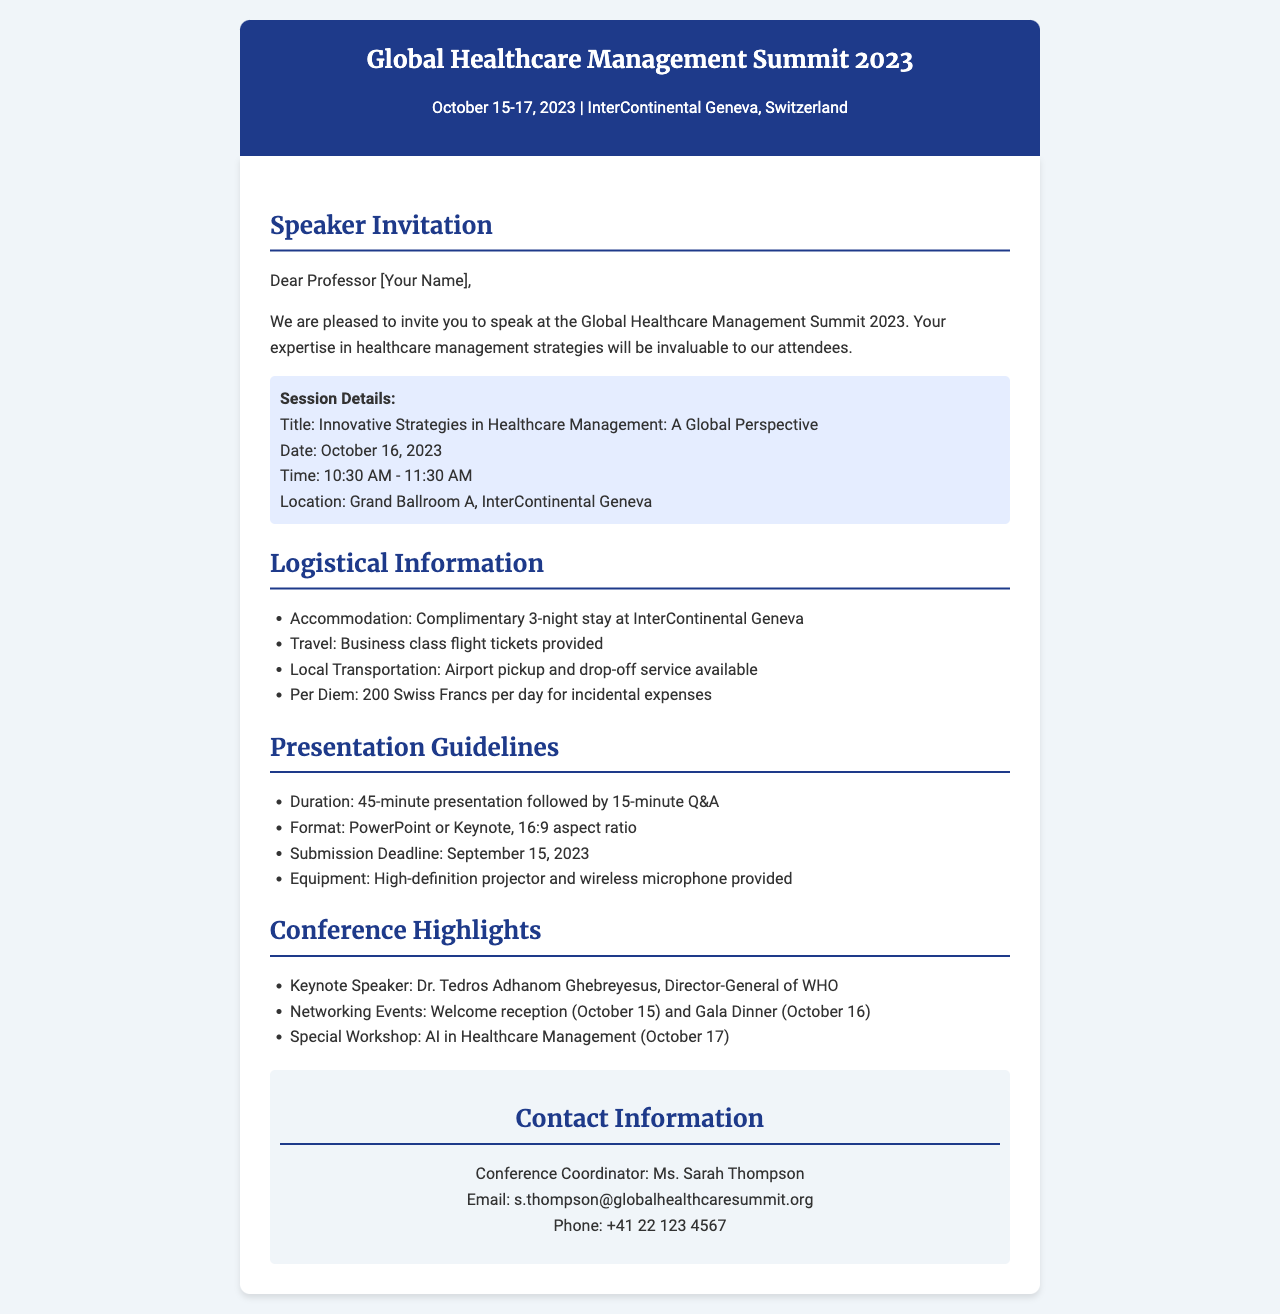What are the dates of the conference? The conference is scheduled to take place from October 15 to October 17, 2023.
Answer: October 15-17, 2023 Who is the keynote speaker? The document specifies that Dr. Tedros Adhanom Ghebreyesus is the keynote speaker.
Answer: Dr. Tedros Adhanom Ghebreyesus What is the title of the session? The session title mentioned in the document is "Innovative Strategies in Healthcare Management: A Global Perspective."
Answer: Innovative Strategies in Healthcare Management: A Global Perspective What is the duration of the presentation? The duration outlined in the document includes a 45-minute presentation followed by a 15-minute Q&A.
Answer: 45 minutes When is the submission deadline for the presentation? The document states that the submission deadline for the presentation is September 15, 2023.
Answer: September 15, 2023 What is provided for travel? According to the logistical information, business class flight tickets are provided for travel.
Answer: Business class flight tickets How much is the per diem for incidental expenses? The per diem amount mentioned in the document is 200 Swiss Francs per day.
Answer: 200 Swiss Francs What is the location of the session? The location specified in the document for the session is Grand Ballroom A, InterContinental Geneva.
Answer: Grand Ballroom A, InterContinental Geneva What type of equipment will be provided for the presentation? The document states that a high-definition projector and wireless microphone will be provided for the presentation.
Answer: High-definition projector and wireless microphone 